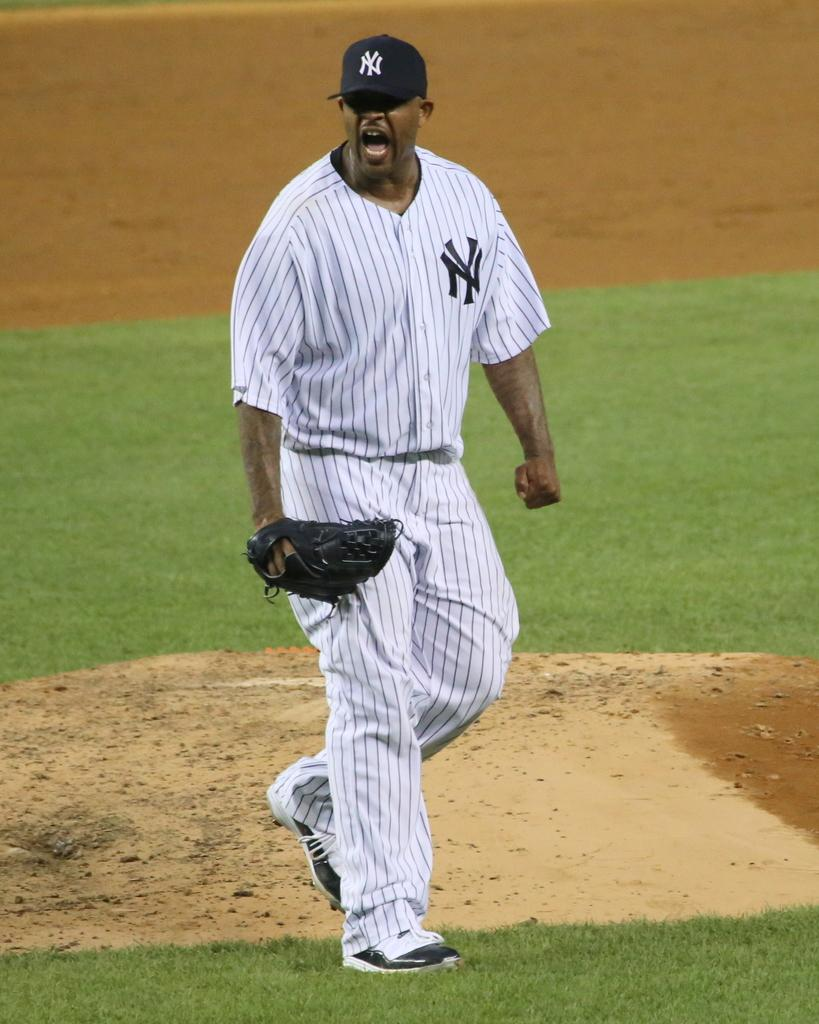<image>
Create a compact narrative representing the image presented. a baseball player yelling in a NY jersey and cap 